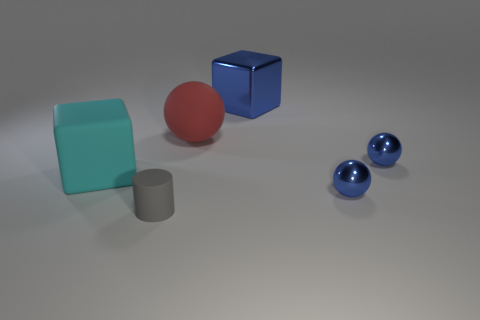Is the number of small purple metal blocks greater than the number of blue metal objects?
Ensure brevity in your answer.  No. Do the gray cylinder and the cyan thing have the same material?
Your response must be concise. Yes. What number of shiny objects are either big cyan objects or blue objects?
Ensure brevity in your answer.  3. What is the color of the rubber block that is the same size as the metal block?
Offer a very short reply. Cyan. How many other shiny things are the same shape as the large blue thing?
Make the answer very short. 0. What number of blocks are large red things or small blue things?
Offer a terse response. 0. There is a blue thing behind the large red sphere; does it have the same shape as the big thing left of the large red rubber thing?
Provide a short and direct response. Yes. What material is the gray cylinder?
Give a very brief answer. Rubber. What number of blue things have the same size as the rubber cube?
Provide a succinct answer. 1. What number of things are big blue metallic blocks behind the cyan cube or cubes behind the matte ball?
Your response must be concise. 1. 